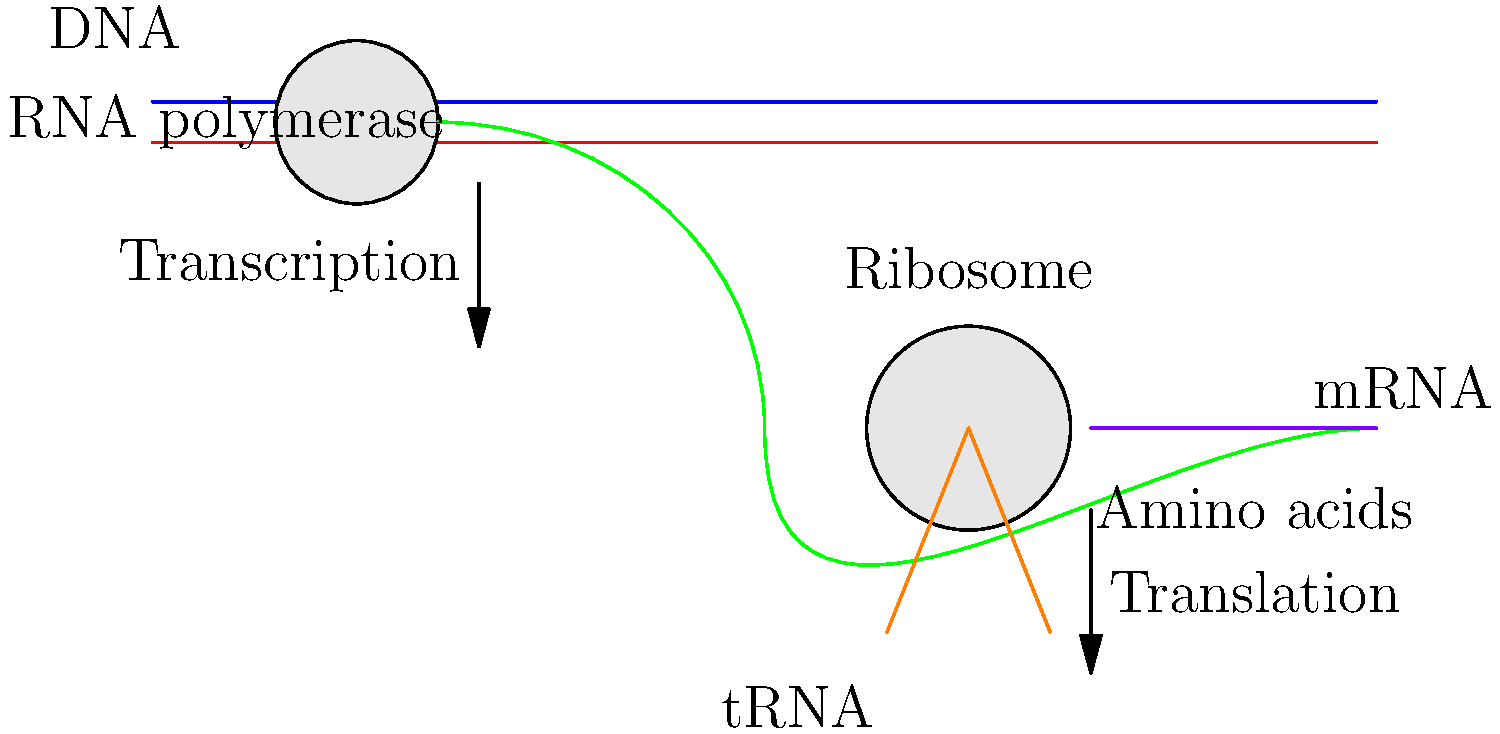In the genetic engineering process depicted, which step occurs first and what is the primary product of this step? To answer this question, let's break down the genetic engineering process shown in the diagram:

1. The diagram illustrates two main processes: transcription and translation.

2. Transcription:
   - Occurs in the upper part of the diagram.
   - Involves DNA (blue and red strands) and RNA polymerase.
   - Produces mRNA (green strand).

3. Translation:
   - Occurs in the lower part of the diagram.
   - Involves mRNA, ribosomes, and tRNA.
   - Produces a chain of amino acids (purple).

4. The order of events:
   - Transcription happens first, as indicated by the "Transcription" arrow pointing downward.
   - Translation follows, as shown by the "Translation" arrow pointing downward from the mRNA to the amino acid chain.

5. The primary product of the first step (transcription) is mRNA, which serves as the template for protein synthesis in the subsequent translation process.

Therefore, transcription occurs first in this genetic engineering process, and its primary product is mRNA.
Answer: Transcription; mRNA 